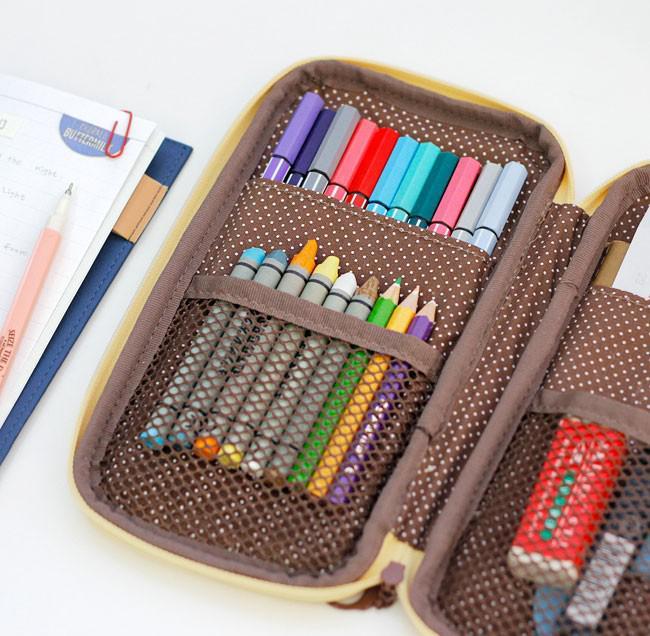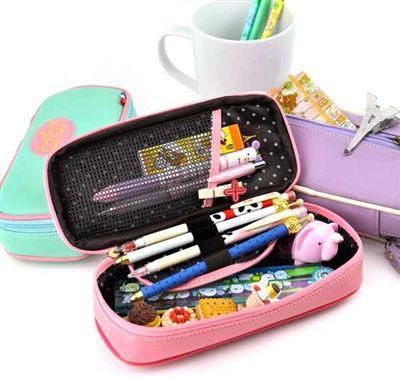The first image is the image on the left, the second image is the image on the right. Considering the images on both sides, is "The left image includes a pair of eyeglasses at least partly visible." valid? Answer yes or no. No. 